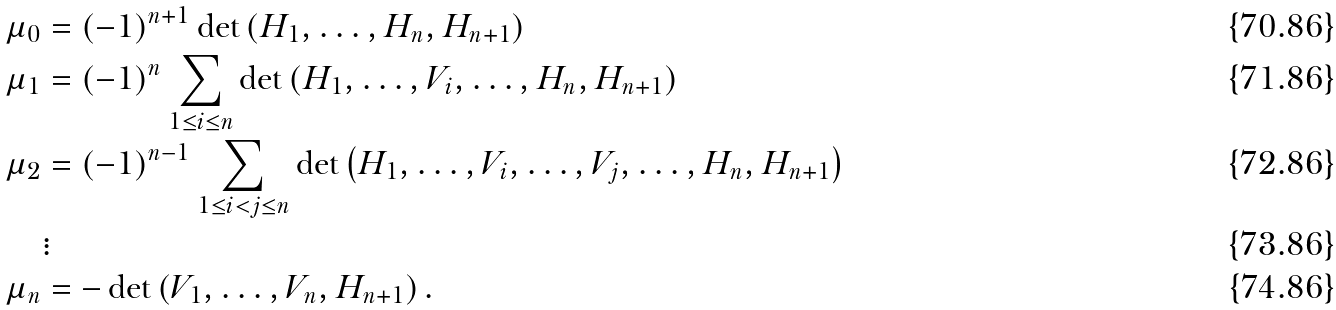Convert formula to latex. <formula><loc_0><loc_0><loc_500><loc_500>\mu _ { 0 } & = ( - 1 ) ^ { n + 1 } \det \left ( H _ { 1 } , \dots , H _ { n } , H _ { n + 1 } \right ) \\ \mu _ { 1 } & = ( - 1 ) ^ { n } \sum _ { 1 \leq i \leq n } \det \left ( H _ { 1 } , \dots , V _ { i } , \dots , H _ { n } , H _ { n + 1 } \right ) \\ \mu _ { 2 } & = ( - 1 ) ^ { n - 1 } \sum _ { 1 \leq i < j \leq n } \det \left ( H _ { 1 } , \dots , V _ { i } , \dots , V _ { j } , \dots , H _ { n } , H _ { n + 1 } \right ) \\ & \vdots \\ \mu _ { n } & = - \det \left ( V _ { 1 } , \dots , V _ { n } , H _ { n + 1 } \right ) .</formula> 